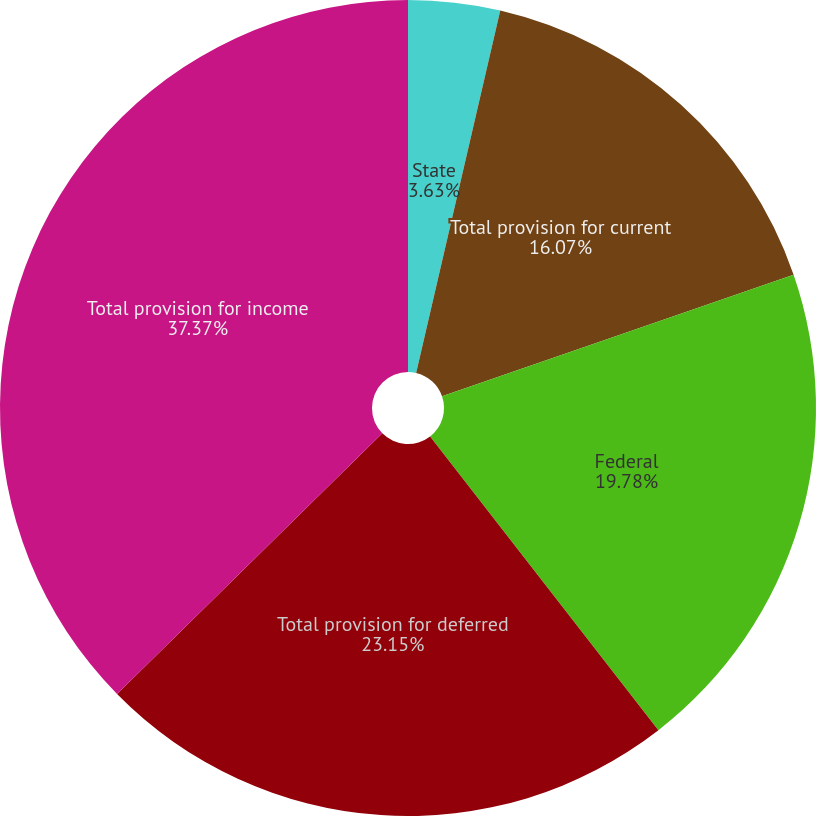Convert chart to OTSL. <chart><loc_0><loc_0><loc_500><loc_500><pie_chart><fcel>State<fcel>Total provision for current<fcel>Federal<fcel>Total provision for deferred<fcel>Total provision for income<nl><fcel>3.63%<fcel>16.07%<fcel>19.78%<fcel>23.15%<fcel>37.36%<nl></chart> 